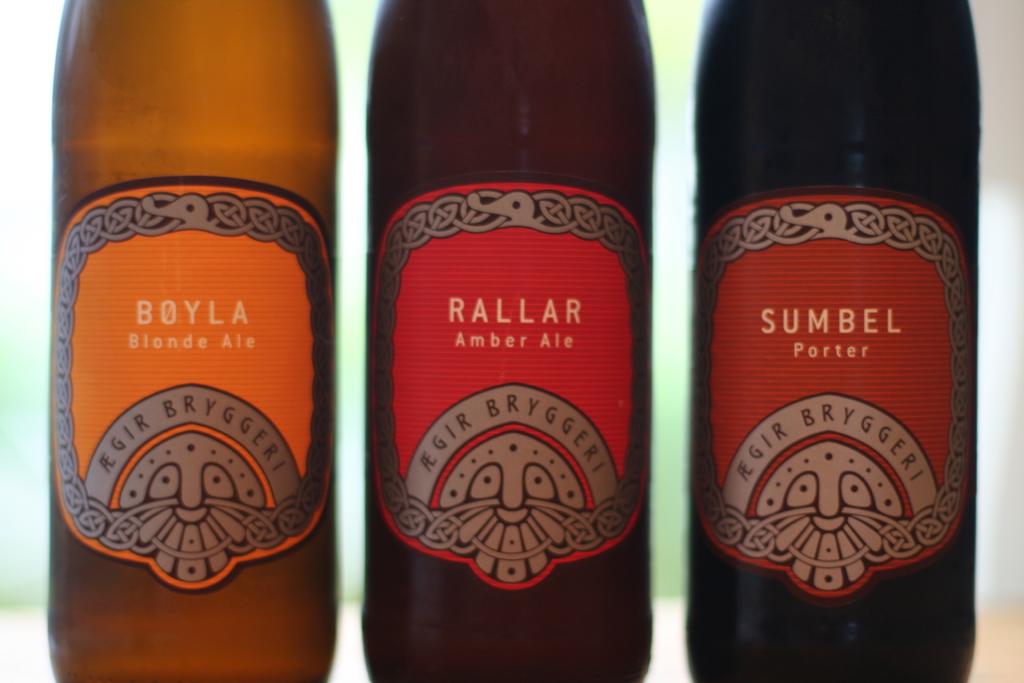What flavour are these drinks?
Ensure brevity in your answer.  Blonde ale, amber ale, porter. What is the brand name of this beer?
Your answer should be very brief. Agir bryggeri. 